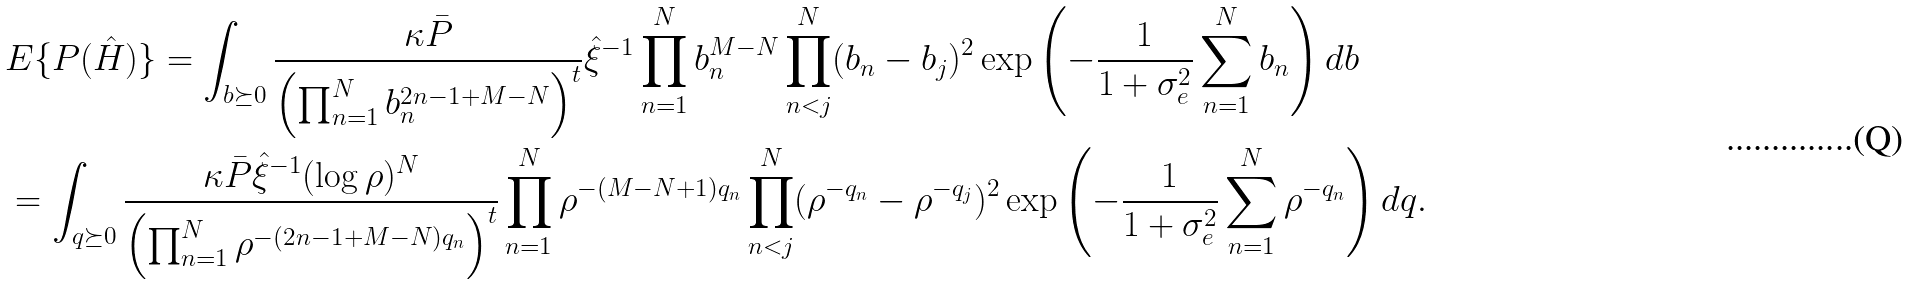Convert formula to latex. <formula><loc_0><loc_0><loc_500><loc_500>& E \{ P ( \hat { H } ) \} = \int _ { b \succeq 0 } \frac { \kappa \bar { P } } { \left ( \prod _ { n = 1 } ^ { N } b _ { n } ^ { 2 n - 1 + M - N } \right ) ^ { t } } \hat { \xi } ^ { - 1 } \prod _ { n = 1 } ^ { N } b _ { n } ^ { M - N } \prod _ { n < j } ^ { N } ( b _ { n } - b _ { j } ) ^ { 2 } \exp \left ( - \frac { 1 } { 1 + \sigma _ { e } ^ { 2 } } \sum _ { n = 1 } ^ { N } b _ { n } \right ) d b \\ & = \int _ { q \succeq 0 } \frac { \kappa \bar { P } \hat { \xi } ^ { - 1 } ( \log \rho ) ^ { N } } { \left ( \prod _ { n = 1 } ^ { N } \rho ^ { - ( 2 n - 1 + M - N ) q _ { n } } \right ) ^ { t } } \prod _ { n = 1 } ^ { N } \rho ^ { - ( M - N + 1 ) q _ { n } } \prod _ { n < j } ^ { N } ( \rho ^ { - q _ { n } } - \rho ^ { - q _ { j } } ) ^ { 2 } \exp \left ( - \frac { 1 } { 1 + \sigma _ { e } ^ { 2 } } \sum _ { n = 1 } ^ { N } \rho ^ { - q _ { n } } \right ) d q .</formula> 